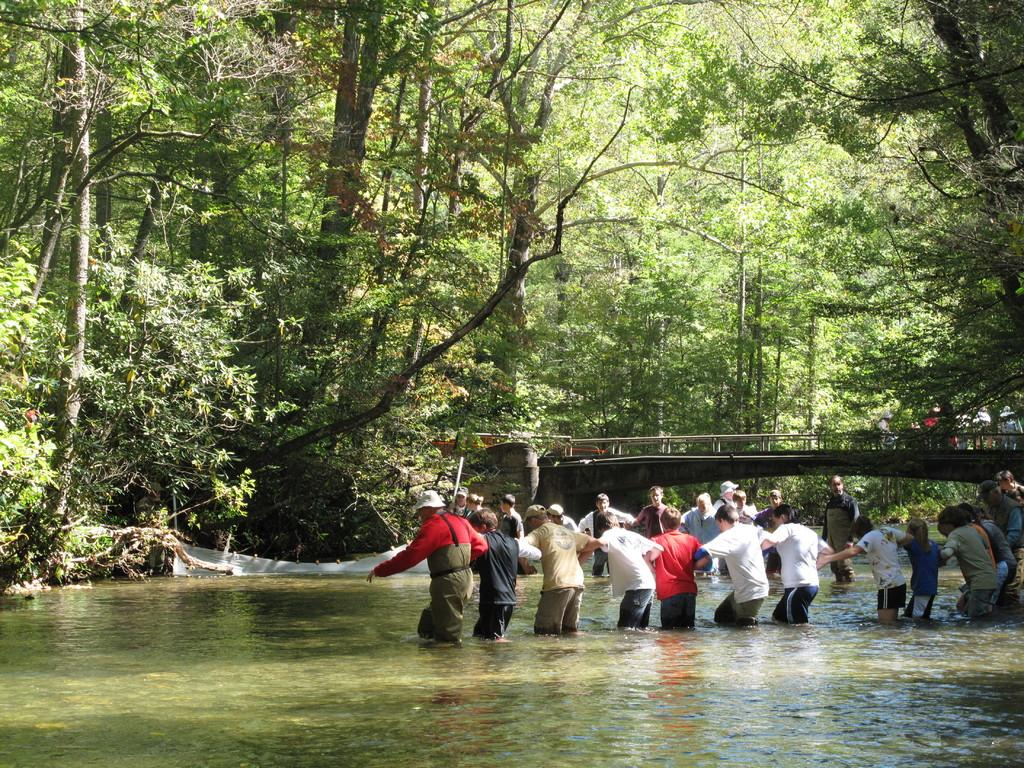What are the people in the image doing? There is a group of people standing in the water. What structure can be seen in the image? There is a bridge in the image. What can be seen in the background of the image? There are trees visible in the background of the image. Can you see any wounds on the people in the image? There is no indication of any wounds on the people in the image. Are there any deer visible in the image? There are no deer present in the image. 